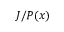<formula> <loc_0><loc_0><loc_500><loc_500>J / P ( x )</formula> 